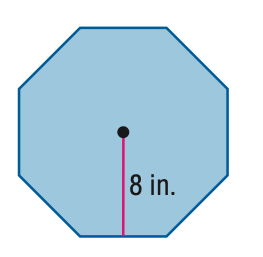Question: Find the area of the regular polygon. Round to the nearest tenth.
Choices:
A. 26.5
B. 106.1
C. 212.1
D. 424.2
Answer with the letter. Answer: C 